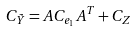Convert formula to latex. <formula><loc_0><loc_0><loc_500><loc_500>C _ { \tilde { Y } } = A C _ { e _ { 1 } } A ^ { T } + C _ { Z }</formula> 